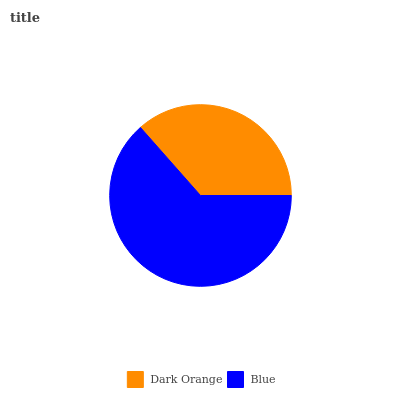Is Dark Orange the minimum?
Answer yes or no. Yes. Is Blue the maximum?
Answer yes or no. Yes. Is Blue the minimum?
Answer yes or no. No. Is Blue greater than Dark Orange?
Answer yes or no. Yes. Is Dark Orange less than Blue?
Answer yes or no. Yes. Is Dark Orange greater than Blue?
Answer yes or no. No. Is Blue less than Dark Orange?
Answer yes or no. No. Is Blue the high median?
Answer yes or no. Yes. Is Dark Orange the low median?
Answer yes or no. Yes. Is Dark Orange the high median?
Answer yes or no. No. Is Blue the low median?
Answer yes or no. No. 